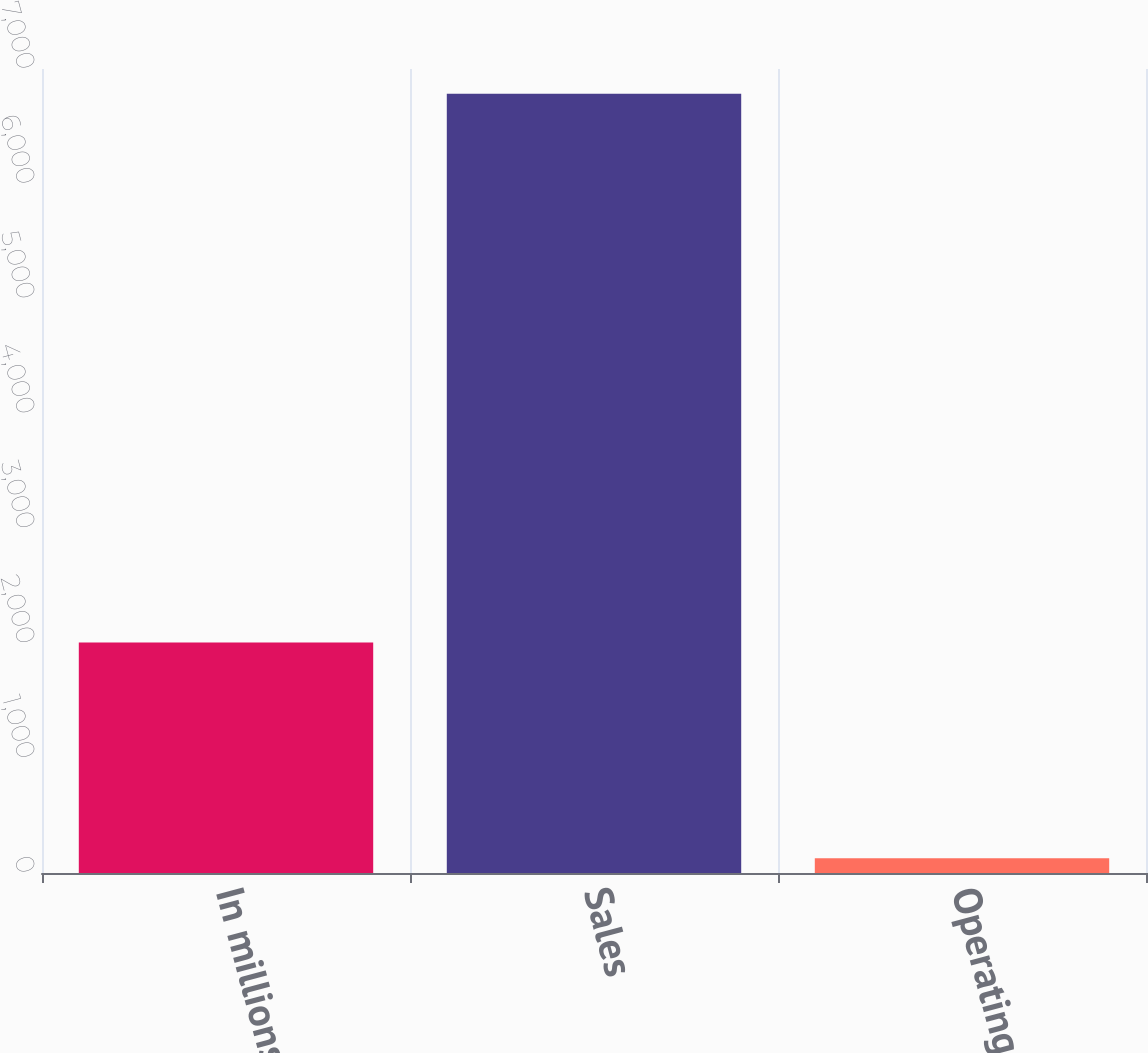Convert chart. <chart><loc_0><loc_0><loc_500><loc_500><bar_chart><fcel>In millions<fcel>Sales<fcel>Operating Profit<nl><fcel>2006<fcel>6785<fcel>128<nl></chart> 